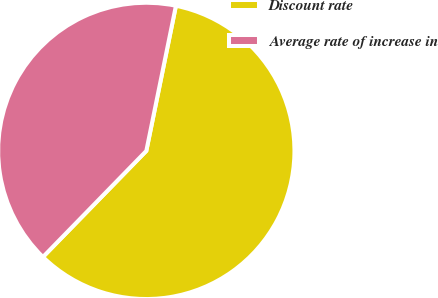Convert chart to OTSL. <chart><loc_0><loc_0><loc_500><loc_500><pie_chart><fcel>Discount rate<fcel>Average rate of increase in<nl><fcel>59.09%<fcel>40.91%<nl></chart> 